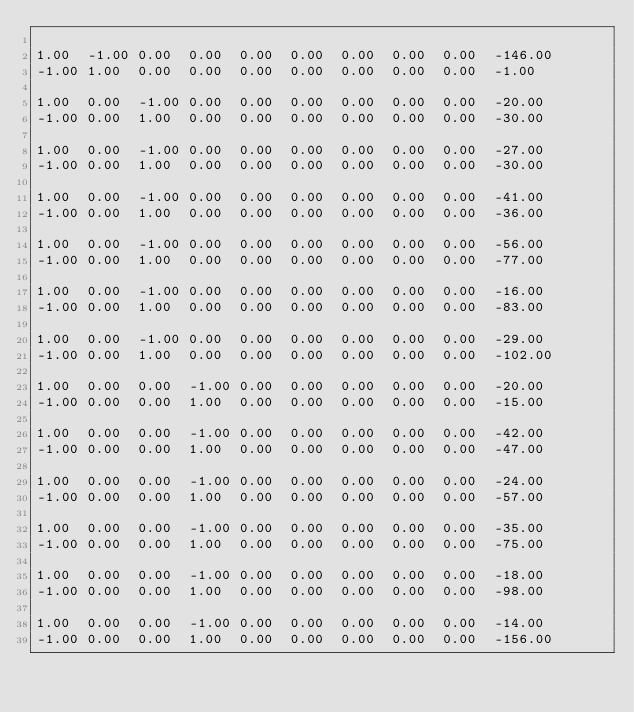Convert code to text. <code><loc_0><loc_0><loc_500><loc_500><_Matlab_>
1.00	-1.00	0.00	0.00	0.00	0.00	0.00	0.00	0.00	-146.00
-1.00	1.00	0.00	0.00	0.00	0.00	0.00	0.00	0.00	-1.00

1.00	0.00	-1.00	0.00	0.00	0.00	0.00	0.00	0.00	-20.00
-1.00	0.00	1.00	0.00	0.00	0.00	0.00	0.00	0.00	-30.00

1.00	0.00	-1.00	0.00	0.00	0.00	0.00	0.00	0.00	-27.00
-1.00	0.00	1.00	0.00	0.00	0.00	0.00	0.00	0.00	-30.00

1.00	0.00	-1.00	0.00	0.00	0.00	0.00	0.00	0.00	-41.00
-1.00	0.00	1.00	0.00	0.00	0.00	0.00	0.00	0.00	-36.00

1.00	0.00	-1.00	0.00	0.00	0.00	0.00	0.00	0.00	-56.00
-1.00	0.00	1.00	0.00	0.00	0.00	0.00	0.00	0.00	-77.00

1.00	0.00	-1.00	0.00	0.00	0.00	0.00	0.00	0.00	-16.00
-1.00	0.00	1.00	0.00	0.00	0.00	0.00	0.00	0.00	-83.00

1.00	0.00	-1.00	0.00	0.00	0.00	0.00	0.00	0.00	-29.00
-1.00	0.00	1.00	0.00	0.00	0.00	0.00	0.00	0.00	-102.00

1.00	0.00	0.00	-1.00	0.00	0.00	0.00	0.00	0.00	-20.00
-1.00	0.00	0.00	1.00	0.00	0.00	0.00	0.00	0.00	-15.00

1.00	0.00	0.00	-1.00	0.00	0.00	0.00	0.00	0.00	-42.00
-1.00	0.00	0.00	1.00	0.00	0.00	0.00	0.00	0.00	-47.00

1.00	0.00	0.00	-1.00	0.00	0.00	0.00	0.00	0.00	-24.00
-1.00	0.00	0.00	1.00	0.00	0.00	0.00	0.00	0.00	-57.00

1.00	0.00	0.00	-1.00	0.00	0.00	0.00	0.00	0.00	-35.00
-1.00	0.00	0.00	1.00	0.00	0.00	0.00	0.00	0.00	-75.00

1.00	0.00	0.00	-1.00	0.00	0.00	0.00	0.00	0.00	-18.00
-1.00	0.00	0.00	1.00	0.00	0.00	0.00	0.00	0.00	-98.00

1.00	0.00	0.00	-1.00	0.00	0.00	0.00	0.00	0.00	-14.00
-1.00	0.00	0.00	1.00	0.00	0.00	0.00	0.00	0.00	-156.00
</code> 